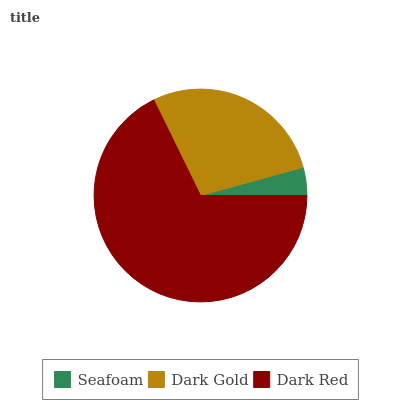Is Seafoam the minimum?
Answer yes or no. Yes. Is Dark Red the maximum?
Answer yes or no. Yes. Is Dark Gold the minimum?
Answer yes or no. No. Is Dark Gold the maximum?
Answer yes or no. No. Is Dark Gold greater than Seafoam?
Answer yes or no. Yes. Is Seafoam less than Dark Gold?
Answer yes or no. Yes. Is Seafoam greater than Dark Gold?
Answer yes or no. No. Is Dark Gold less than Seafoam?
Answer yes or no. No. Is Dark Gold the high median?
Answer yes or no. Yes. Is Dark Gold the low median?
Answer yes or no. Yes. Is Dark Red the high median?
Answer yes or no. No. Is Seafoam the low median?
Answer yes or no. No. 